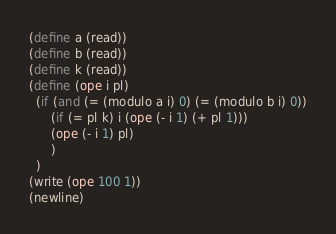<code> <loc_0><loc_0><loc_500><loc_500><_Scheme_>(define a (read))
(define b (read))
(define k (read))
(define (ope i pl)
  (if (and (= (modulo a i) 0) (= (modulo b i) 0))
      (if (= pl k) i (ope (- i 1) (+ pl 1)))
      (ope (- i 1) pl)
      )
  )
(write (ope 100 1))
(newline)</code> 